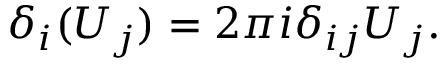Convert formula to latex. <formula><loc_0><loc_0><loc_500><loc_500>\delta _ { i } ( U _ { j } ) = 2 \pi i \delta _ { i j } U _ { j } .</formula> 